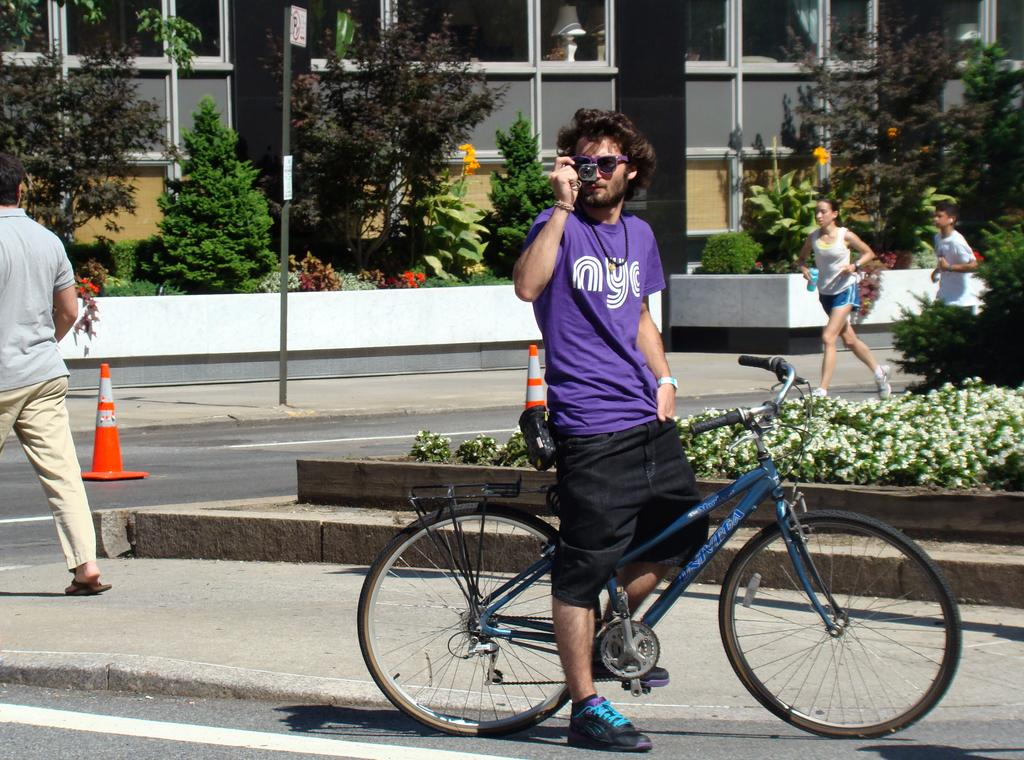What is the person in the image doing? The person is taking a picture. What is the person wearing in the image? The person is wearing a blue shirt and black shorts. What mode of transportation is the person using in the image? The person is on a bicycle. What can be seen in the background of the image? There are plants visible in the background, and two ladies are walking. What type of dinosaurs can be seen in the image? There are no dinosaurs present in the image. How much payment is being made for the picture in the image? There is no indication of payment being made in the image. 